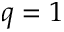<formula> <loc_0><loc_0><loc_500><loc_500>q = 1</formula> 